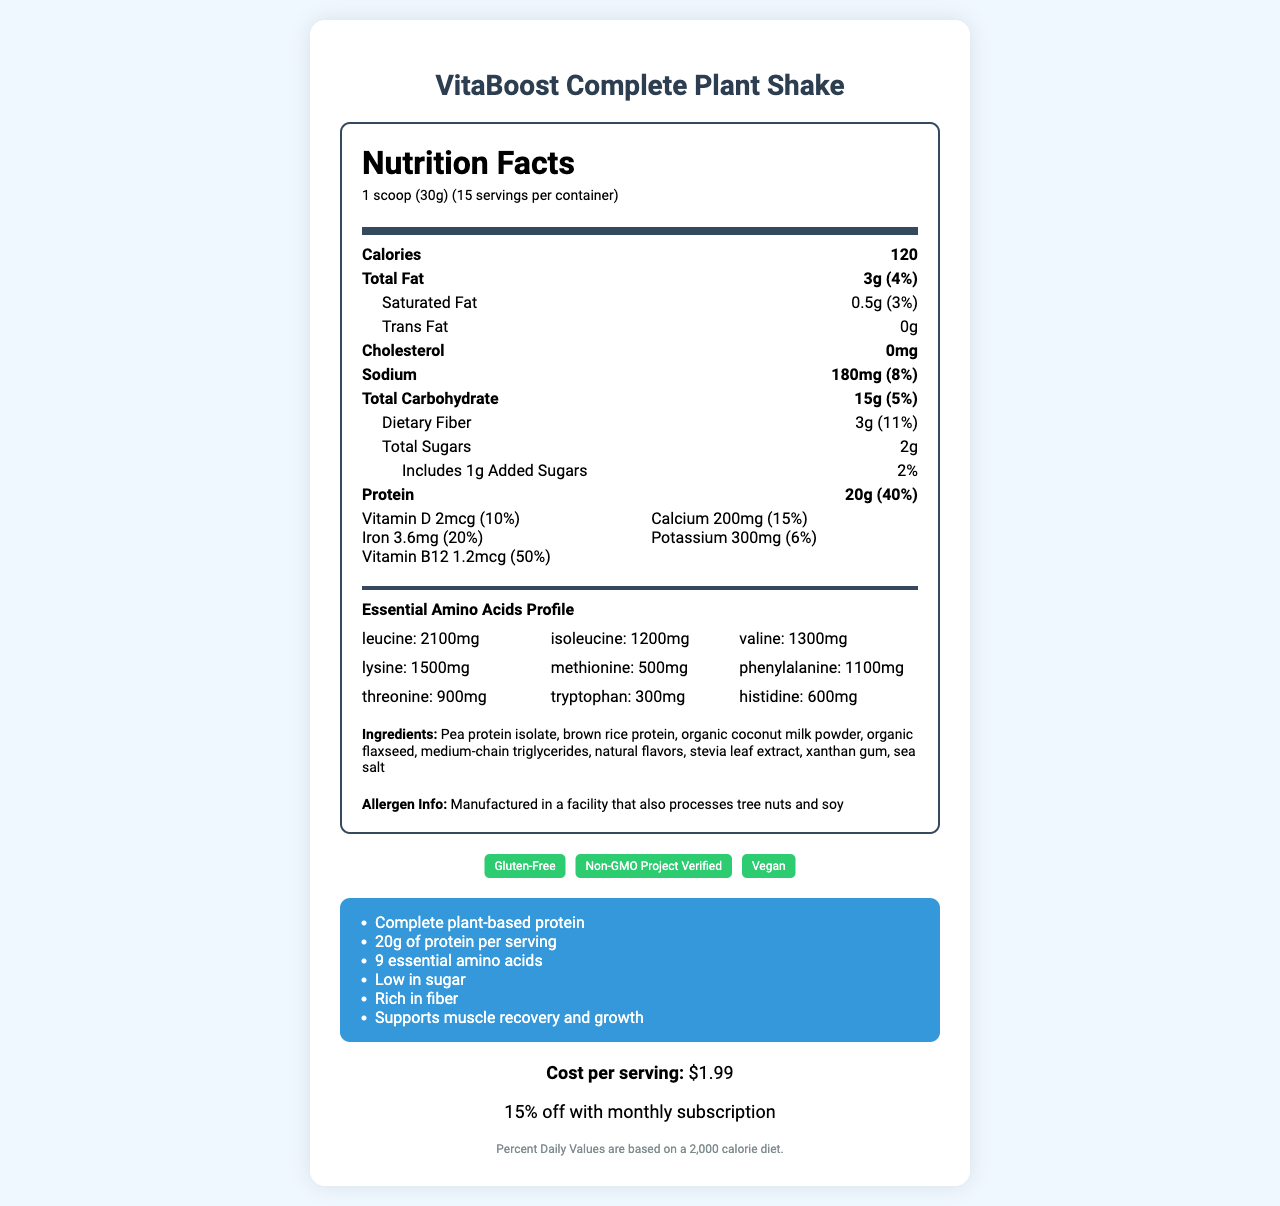what is the serving size for VitaBoost Complete Plant Shake? The serving size is directly mentioned under the product name.
Answer: 1 scoop (30g) how many servings are there per container? It is indicated as "15 servings per container" in the serving information section.
Answer: 15 servings how many grams of protein are in each serving? The document specifies that each serving contains 20 grams of protein.
Answer: 20g what percentage of the daily value of vitamin B12 is provided per serving? The amount and percent daily value of vitamin B12 per serving is listed in the vitamins and minerals section.
Answer: 50% what is the amount of dietary fiber in each serving? Each serving contains 3 grams of dietary fiber, as shown in the nutrition facts.
Answer: 3g which of the following ingredients is NOT listed? A. Pea protein isolate B. Brown rice protein C. Whey protein Whey protein is not listed amongst the ingredients; instead, plant-based proteins like pea protein isolate and brown rice protein are mentioned.
Answer: C what is the cost per serving? The cost per serving is clearly stated in the pricing section.
Answer: $1.99 what is the percentage of daily value for calcium per serving? The percent daily value for calcium is mentioned as 15% in the vitamins and minerals section.
Answer: 15% what allergen information is provided on the label? The allergen info note mentions potential exposure to tree nuts and soy.
Answer: Manufactured in a facility that also processes tree nuts and soy does the product contain any cholesterol? The document mentions 0mg cholesterol, indicating that there is no cholesterol in the product.
Answer: No describe the main features and nutritional highlights of the VitaBoost Complete Plant Shake. The main features were summarized from the nutrition facts, marketing claims, and certifications sections in the document.
Answer: The VitaBoost Complete Plant Shake is a gluten-free, plant-based meal replacement shake with a complete amino acid profile. Each serving (1 scoop of 30g) contains 120 calories, 3g of fat, 15g of carbohydrates, 3g of dietary fiber, and 20g of protein. The shake includes various vitamins and minerals such as vitamin D, calcium, iron, potassium, and vitamin B12. It is also certified gluten-free, non-GMO, and vegan. The product supports muscle recovery and growth and is low in sugar. which essential amino acid is present in the highest amount? Leucine is listed at 2100mg, which is the highest among the essential amino acids mentioned.
Answer: Leucine how many grams of added sugars are there per serving? The label shows that there is 1 gram of added sugars per serving.
Answer: 1g what is the total amount of sodium in each serving? Each serving contains 180mg of sodium as specified in the nutrition facts section.
Answer: 180mg what are the certifications of the VitaBoost Complete Plant Shake? A. Gluten-Free B. Non-GMO Project Verified C. Organic D. Vegan The correct certifications listed are Gluten-Free, Non-GMO Project Verified, and Vegan. Organic was not mentioned.
Answer: A, B, D can you determine the manufacturing location from the information provided? The document does not provide any information regarding the manufacturing location of the VitaBoost Complete Plant Shake.
Answer: Not enough information 